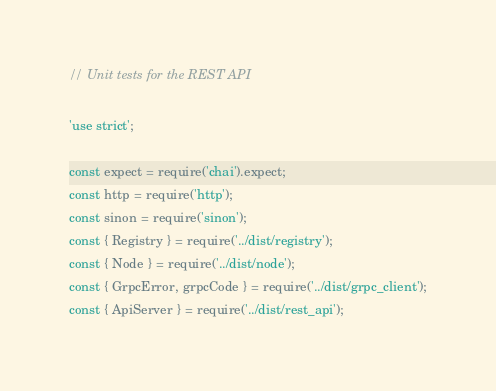Convert code to text. <code><loc_0><loc_0><loc_500><loc_500><_JavaScript_>// Unit tests for the REST API

'use strict';

const expect = require('chai').expect;
const http = require('http');
const sinon = require('sinon');
const { Registry } = require('../dist/registry');
const { Node } = require('../dist/node');
const { GrpcError, grpcCode } = require('../dist/grpc_client');
const { ApiServer } = require('../dist/rest_api');
</code> 